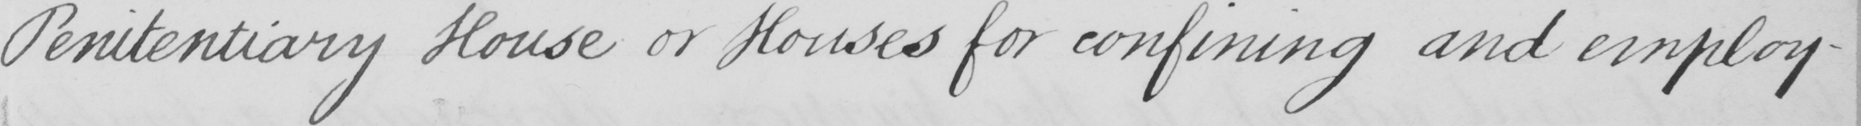What is written in this line of handwriting? Penitentiary House or Houses for confining and employ- 